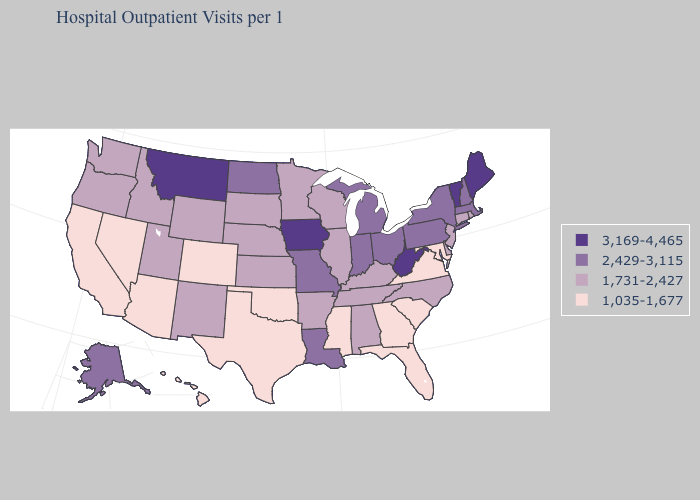Does Vermont have the highest value in the USA?
Be succinct. Yes. Which states hav the highest value in the MidWest?
Be succinct. Iowa. Does Maryland have the lowest value in the USA?
Concise answer only. Yes. Among the states that border Connecticut , which have the highest value?
Give a very brief answer. Massachusetts, New York. Which states have the lowest value in the West?
Write a very short answer. Arizona, California, Colorado, Hawaii, Nevada. What is the lowest value in the USA?
Write a very short answer. 1,035-1,677. Which states have the lowest value in the USA?
Give a very brief answer. Arizona, California, Colorado, Florida, Georgia, Hawaii, Maryland, Mississippi, Nevada, Oklahoma, South Carolina, Texas, Virginia. Does Colorado have a higher value than New York?
Give a very brief answer. No. What is the highest value in states that border California?
Give a very brief answer. 1,731-2,427. Does Colorado have the lowest value in the USA?
Give a very brief answer. Yes. What is the value of Montana?
Concise answer only. 3,169-4,465. Name the states that have a value in the range 1,035-1,677?
Concise answer only. Arizona, California, Colorado, Florida, Georgia, Hawaii, Maryland, Mississippi, Nevada, Oklahoma, South Carolina, Texas, Virginia. Which states hav the highest value in the Northeast?
Concise answer only. Maine, Vermont. What is the value of New York?
Write a very short answer. 2,429-3,115. Does Maine have the lowest value in the Northeast?
Write a very short answer. No. 